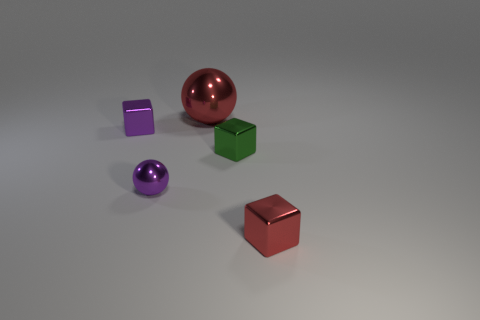There is a ball in front of the small purple metallic thing that is behind the small metallic sphere; how big is it?
Provide a short and direct response. Small. Is there a tiny purple block made of the same material as the tiny green thing?
Your response must be concise. Yes. What material is the purple sphere that is the same size as the green cube?
Ensure brevity in your answer.  Metal. There is a ball that is in front of the tiny purple block; does it have the same color as the tiny cube on the right side of the green shiny object?
Provide a succinct answer. No. Is there a green cube that is in front of the metal sphere that is in front of the big shiny object?
Ensure brevity in your answer.  No. There is a red metal thing that is on the right side of the large red object; is it the same shape as the large metallic object that is behind the small green block?
Offer a very short reply. No. Does the purple thing that is in front of the green metallic cube have the same material as the red thing that is in front of the big red sphere?
Your answer should be very brief. Yes. There is a red object to the left of the red metal object in front of the big red thing; what is it made of?
Give a very brief answer. Metal. There is a metal object that is on the left side of the metal sphere that is in front of the small shiny cube to the left of the tiny purple sphere; what shape is it?
Provide a short and direct response. Cube. There is a small purple object that is the same shape as the large red thing; what material is it?
Offer a terse response. Metal. 